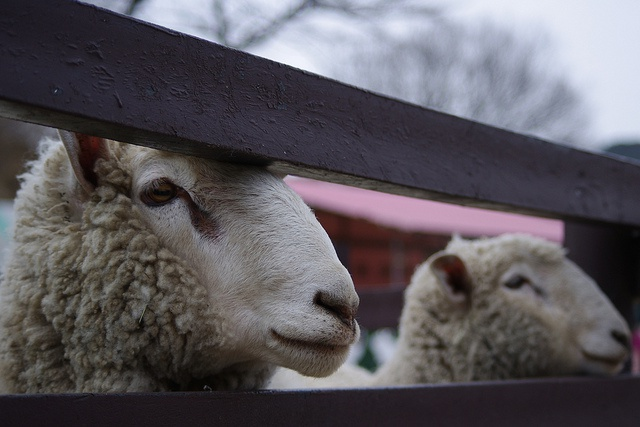Describe the objects in this image and their specific colors. I can see sheep in black, gray, and darkgray tones and sheep in black, gray, and darkgray tones in this image. 